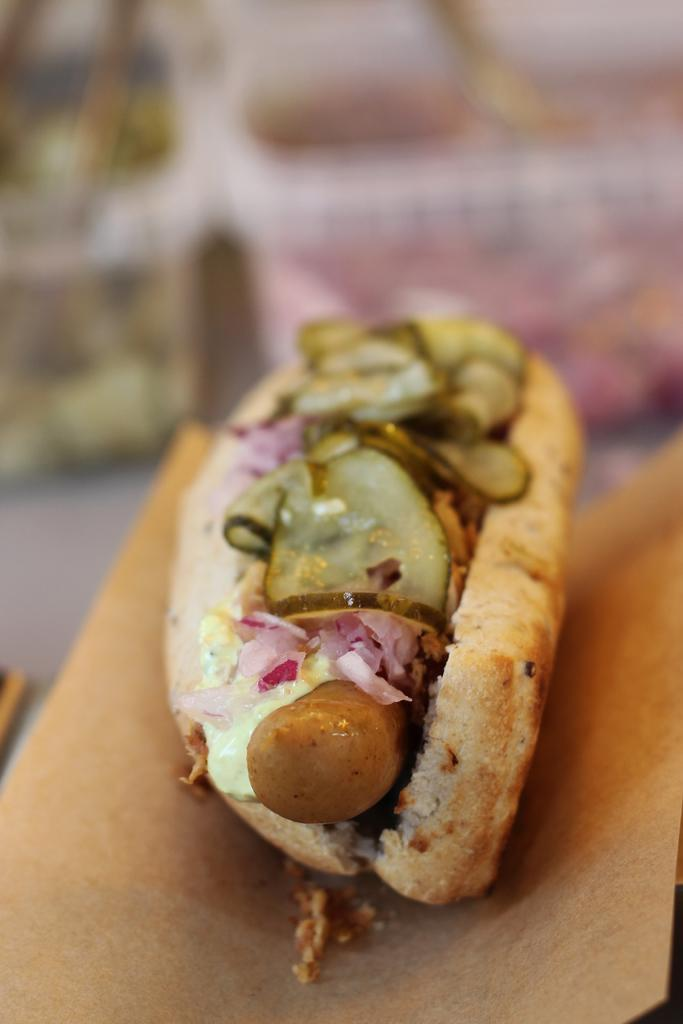What is present on the paper in the image? There is food on a paper in the image. How many eyes can be seen on the food in the image? There are no eyes present on the food in the image. Is there a hand holding the paper with food in the image? The image does not show a hand holding the paper with food. Is the food on a bed in the image? The image does not show the food on a bed; it is on a paper. 